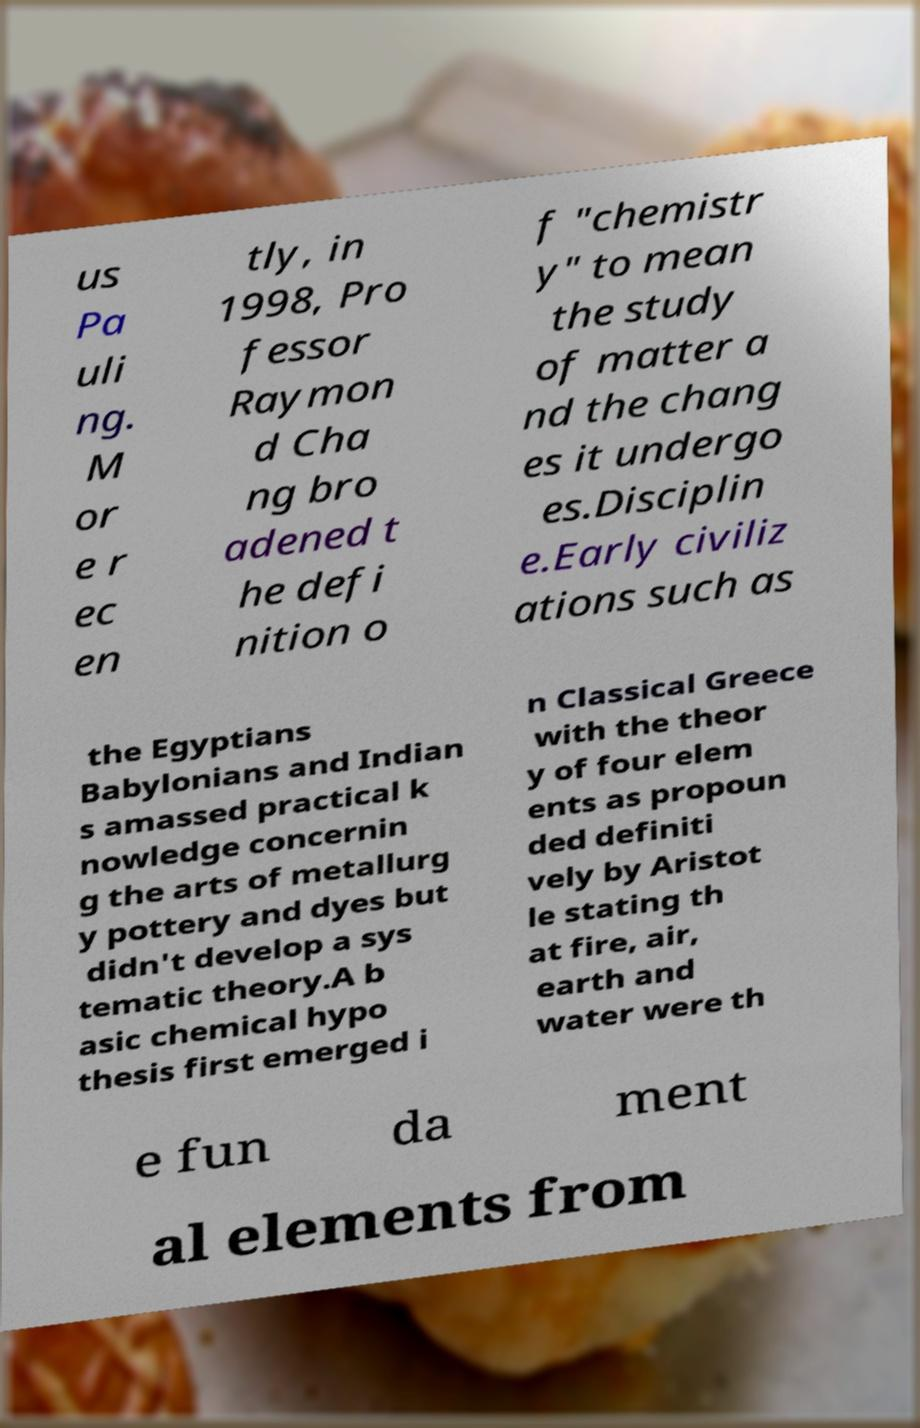Can you read and provide the text displayed in the image?This photo seems to have some interesting text. Can you extract and type it out for me? us Pa uli ng. M or e r ec en tly, in 1998, Pro fessor Raymon d Cha ng bro adened t he defi nition o f "chemistr y" to mean the study of matter a nd the chang es it undergo es.Disciplin e.Early civiliz ations such as the Egyptians Babylonians and Indian s amassed practical k nowledge concernin g the arts of metallurg y pottery and dyes but didn't develop a sys tematic theory.A b asic chemical hypo thesis first emerged i n Classical Greece with the theor y of four elem ents as propoun ded definiti vely by Aristot le stating th at fire, air, earth and water were th e fun da ment al elements from 